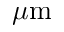<formula> <loc_0><loc_0><loc_500><loc_500>\mu m</formula> 